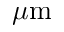<formula> <loc_0><loc_0><loc_500><loc_500>\mu m</formula> 